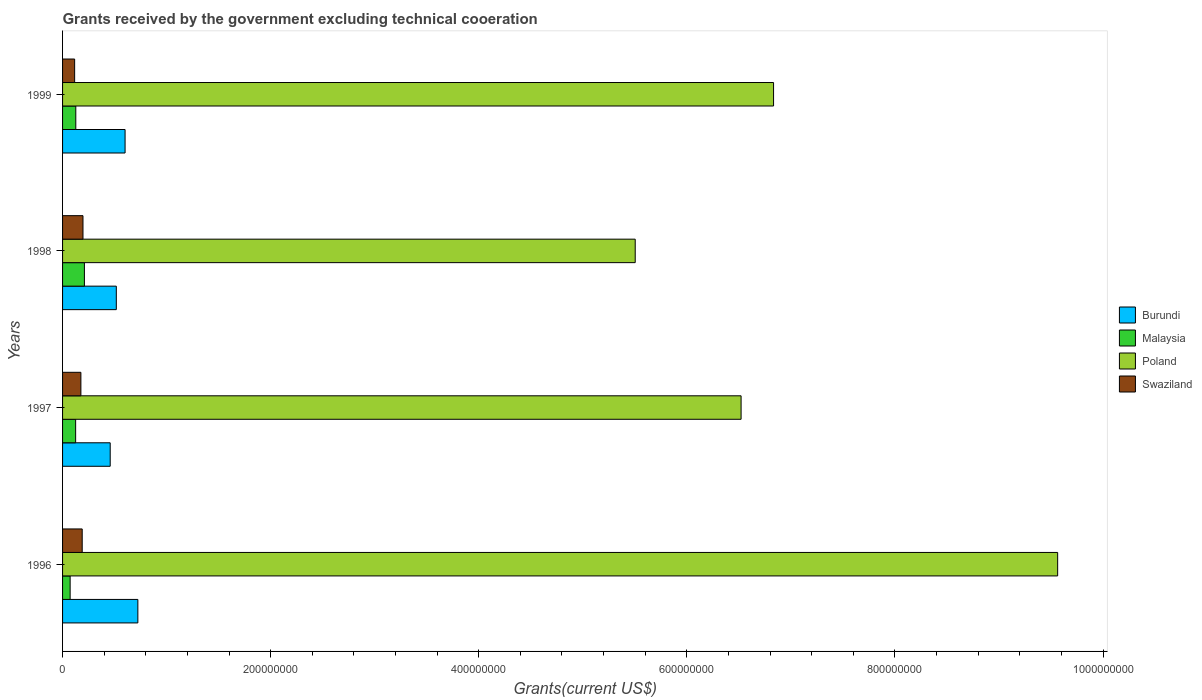How many different coloured bars are there?
Give a very brief answer. 4. Are the number of bars on each tick of the Y-axis equal?
Your answer should be very brief. Yes. How many bars are there on the 4th tick from the top?
Provide a succinct answer. 4. What is the total grants received by the government in Burundi in 1998?
Keep it short and to the point. 5.17e+07. Across all years, what is the maximum total grants received by the government in Malaysia?
Offer a very short reply. 2.10e+07. Across all years, what is the minimum total grants received by the government in Burundi?
Make the answer very short. 4.58e+07. In which year was the total grants received by the government in Malaysia maximum?
Offer a very short reply. 1998. What is the total total grants received by the government in Burundi in the graph?
Make the answer very short. 2.30e+08. What is the difference between the total grants received by the government in Poland in 1997 and that in 1999?
Give a very brief answer. -3.12e+07. What is the difference between the total grants received by the government in Poland in 1997 and the total grants received by the government in Burundi in 1999?
Your answer should be very brief. 5.92e+08. What is the average total grants received by the government in Malaysia per year?
Ensure brevity in your answer.  1.34e+07. In the year 1996, what is the difference between the total grants received by the government in Malaysia and total grants received by the government in Swaziland?
Make the answer very short. -1.16e+07. In how many years, is the total grants received by the government in Swaziland greater than 480000000 US$?
Ensure brevity in your answer.  0. What is the ratio of the total grants received by the government in Burundi in 1997 to that in 1998?
Offer a terse response. 0.89. Is the total grants received by the government in Malaysia in 1996 less than that in 1997?
Keep it short and to the point. Yes. Is the difference between the total grants received by the government in Malaysia in 1998 and 1999 greater than the difference between the total grants received by the government in Swaziland in 1998 and 1999?
Offer a very short reply. Yes. What is the difference between the highest and the second highest total grants received by the government in Burundi?
Offer a terse response. 1.23e+07. What is the difference between the highest and the lowest total grants received by the government in Swaziland?
Your answer should be very brief. 8.02e+06. Is the sum of the total grants received by the government in Burundi in 1997 and 1998 greater than the maximum total grants received by the government in Poland across all years?
Offer a terse response. No. What does the 4th bar from the bottom in 1998 represents?
Keep it short and to the point. Swaziland. Is it the case that in every year, the sum of the total grants received by the government in Burundi and total grants received by the government in Malaysia is greater than the total grants received by the government in Swaziland?
Offer a terse response. Yes. How many bars are there?
Offer a very short reply. 16. How many years are there in the graph?
Offer a very short reply. 4. How many legend labels are there?
Make the answer very short. 4. How are the legend labels stacked?
Offer a very short reply. Vertical. What is the title of the graph?
Give a very brief answer. Grants received by the government excluding technical cooeration. What is the label or title of the X-axis?
Your answer should be compact. Grants(current US$). What is the Grants(current US$) of Burundi in 1996?
Provide a short and direct response. 7.24e+07. What is the Grants(current US$) of Malaysia in 1996?
Provide a short and direct response. 7.28e+06. What is the Grants(current US$) of Poland in 1996?
Give a very brief answer. 9.56e+08. What is the Grants(current US$) of Swaziland in 1996?
Provide a short and direct response. 1.89e+07. What is the Grants(current US$) of Burundi in 1997?
Provide a succinct answer. 4.58e+07. What is the Grants(current US$) in Malaysia in 1997?
Your response must be concise. 1.26e+07. What is the Grants(current US$) of Poland in 1997?
Offer a very short reply. 6.52e+08. What is the Grants(current US$) of Swaziland in 1997?
Make the answer very short. 1.76e+07. What is the Grants(current US$) of Burundi in 1998?
Offer a terse response. 5.17e+07. What is the Grants(current US$) of Malaysia in 1998?
Give a very brief answer. 2.10e+07. What is the Grants(current US$) of Poland in 1998?
Provide a short and direct response. 5.50e+08. What is the Grants(current US$) of Swaziland in 1998?
Offer a terse response. 1.96e+07. What is the Grants(current US$) in Burundi in 1999?
Keep it short and to the point. 6.01e+07. What is the Grants(current US$) in Malaysia in 1999?
Ensure brevity in your answer.  1.27e+07. What is the Grants(current US$) of Poland in 1999?
Make the answer very short. 6.83e+08. What is the Grants(current US$) in Swaziland in 1999?
Your answer should be very brief. 1.16e+07. Across all years, what is the maximum Grants(current US$) in Burundi?
Make the answer very short. 7.24e+07. Across all years, what is the maximum Grants(current US$) in Malaysia?
Give a very brief answer. 2.10e+07. Across all years, what is the maximum Grants(current US$) of Poland?
Ensure brevity in your answer.  9.56e+08. Across all years, what is the maximum Grants(current US$) in Swaziland?
Your answer should be very brief. 1.96e+07. Across all years, what is the minimum Grants(current US$) of Burundi?
Your response must be concise. 4.58e+07. Across all years, what is the minimum Grants(current US$) of Malaysia?
Your answer should be very brief. 7.28e+06. Across all years, what is the minimum Grants(current US$) in Poland?
Your answer should be very brief. 5.50e+08. Across all years, what is the minimum Grants(current US$) of Swaziland?
Provide a succinct answer. 1.16e+07. What is the total Grants(current US$) in Burundi in the graph?
Your response must be concise. 2.30e+08. What is the total Grants(current US$) in Malaysia in the graph?
Give a very brief answer. 5.36e+07. What is the total Grants(current US$) of Poland in the graph?
Your answer should be compact. 2.84e+09. What is the total Grants(current US$) of Swaziland in the graph?
Offer a very short reply. 6.77e+07. What is the difference between the Grants(current US$) in Burundi in 1996 and that in 1997?
Keep it short and to the point. 2.66e+07. What is the difference between the Grants(current US$) of Malaysia in 1996 and that in 1997?
Give a very brief answer. -5.29e+06. What is the difference between the Grants(current US$) of Poland in 1996 and that in 1997?
Your response must be concise. 3.04e+08. What is the difference between the Grants(current US$) of Swaziland in 1996 and that in 1997?
Ensure brevity in your answer.  1.27e+06. What is the difference between the Grants(current US$) in Burundi in 1996 and that in 1998?
Make the answer very short. 2.07e+07. What is the difference between the Grants(current US$) in Malaysia in 1996 and that in 1998?
Your answer should be very brief. -1.37e+07. What is the difference between the Grants(current US$) in Poland in 1996 and that in 1998?
Make the answer very short. 4.06e+08. What is the difference between the Grants(current US$) in Swaziland in 1996 and that in 1998?
Provide a succinct answer. -7.40e+05. What is the difference between the Grants(current US$) of Burundi in 1996 and that in 1999?
Your answer should be very brief. 1.23e+07. What is the difference between the Grants(current US$) of Malaysia in 1996 and that in 1999?
Keep it short and to the point. -5.43e+06. What is the difference between the Grants(current US$) in Poland in 1996 and that in 1999?
Ensure brevity in your answer.  2.73e+08. What is the difference between the Grants(current US$) of Swaziland in 1996 and that in 1999?
Your answer should be compact. 7.28e+06. What is the difference between the Grants(current US$) of Burundi in 1997 and that in 1998?
Make the answer very short. -5.87e+06. What is the difference between the Grants(current US$) in Malaysia in 1997 and that in 1998?
Offer a terse response. -8.42e+06. What is the difference between the Grants(current US$) of Poland in 1997 and that in 1998?
Provide a short and direct response. 1.02e+08. What is the difference between the Grants(current US$) in Swaziland in 1997 and that in 1998?
Ensure brevity in your answer.  -2.01e+06. What is the difference between the Grants(current US$) of Burundi in 1997 and that in 1999?
Ensure brevity in your answer.  -1.43e+07. What is the difference between the Grants(current US$) in Poland in 1997 and that in 1999?
Offer a very short reply. -3.12e+07. What is the difference between the Grants(current US$) of Swaziland in 1997 and that in 1999?
Make the answer very short. 6.01e+06. What is the difference between the Grants(current US$) of Burundi in 1998 and that in 1999?
Make the answer very short. -8.42e+06. What is the difference between the Grants(current US$) in Malaysia in 1998 and that in 1999?
Offer a terse response. 8.28e+06. What is the difference between the Grants(current US$) in Poland in 1998 and that in 1999?
Offer a very short reply. -1.33e+08. What is the difference between the Grants(current US$) of Swaziland in 1998 and that in 1999?
Make the answer very short. 8.02e+06. What is the difference between the Grants(current US$) in Burundi in 1996 and the Grants(current US$) in Malaysia in 1997?
Provide a short and direct response. 5.98e+07. What is the difference between the Grants(current US$) in Burundi in 1996 and the Grants(current US$) in Poland in 1997?
Make the answer very short. -5.80e+08. What is the difference between the Grants(current US$) in Burundi in 1996 and the Grants(current US$) in Swaziland in 1997?
Provide a short and direct response. 5.48e+07. What is the difference between the Grants(current US$) of Malaysia in 1996 and the Grants(current US$) of Poland in 1997?
Provide a short and direct response. -6.45e+08. What is the difference between the Grants(current US$) of Malaysia in 1996 and the Grants(current US$) of Swaziland in 1997?
Your response must be concise. -1.03e+07. What is the difference between the Grants(current US$) in Poland in 1996 and the Grants(current US$) in Swaziland in 1997?
Provide a short and direct response. 9.39e+08. What is the difference between the Grants(current US$) in Burundi in 1996 and the Grants(current US$) in Malaysia in 1998?
Keep it short and to the point. 5.14e+07. What is the difference between the Grants(current US$) in Burundi in 1996 and the Grants(current US$) in Poland in 1998?
Provide a succinct answer. -4.78e+08. What is the difference between the Grants(current US$) of Burundi in 1996 and the Grants(current US$) of Swaziland in 1998?
Provide a succinct answer. 5.27e+07. What is the difference between the Grants(current US$) of Malaysia in 1996 and the Grants(current US$) of Poland in 1998?
Make the answer very short. -5.43e+08. What is the difference between the Grants(current US$) in Malaysia in 1996 and the Grants(current US$) in Swaziland in 1998?
Your answer should be compact. -1.23e+07. What is the difference between the Grants(current US$) in Poland in 1996 and the Grants(current US$) in Swaziland in 1998?
Your answer should be very brief. 9.37e+08. What is the difference between the Grants(current US$) in Burundi in 1996 and the Grants(current US$) in Malaysia in 1999?
Your response must be concise. 5.96e+07. What is the difference between the Grants(current US$) in Burundi in 1996 and the Grants(current US$) in Poland in 1999?
Your answer should be compact. -6.11e+08. What is the difference between the Grants(current US$) in Burundi in 1996 and the Grants(current US$) in Swaziland in 1999?
Offer a terse response. 6.08e+07. What is the difference between the Grants(current US$) of Malaysia in 1996 and the Grants(current US$) of Poland in 1999?
Give a very brief answer. -6.76e+08. What is the difference between the Grants(current US$) of Malaysia in 1996 and the Grants(current US$) of Swaziland in 1999?
Your answer should be compact. -4.32e+06. What is the difference between the Grants(current US$) of Poland in 1996 and the Grants(current US$) of Swaziland in 1999?
Offer a very short reply. 9.45e+08. What is the difference between the Grants(current US$) of Burundi in 1997 and the Grants(current US$) of Malaysia in 1998?
Keep it short and to the point. 2.48e+07. What is the difference between the Grants(current US$) in Burundi in 1997 and the Grants(current US$) in Poland in 1998?
Ensure brevity in your answer.  -5.05e+08. What is the difference between the Grants(current US$) in Burundi in 1997 and the Grants(current US$) in Swaziland in 1998?
Ensure brevity in your answer.  2.62e+07. What is the difference between the Grants(current US$) in Malaysia in 1997 and the Grants(current US$) in Poland in 1998?
Provide a short and direct response. -5.38e+08. What is the difference between the Grants(current US$) of Malaysia in 1997 and the Grants(current US$) of Swaziland in 1998?
Offer a terse response. -7.05e+06. What is the difference between the Grants(current US$) in Poland in 1997 and the Grants(current US$) in Swaziland in 1998?
Ensure brevity in your answer.  6.33e+08. What is the difference between the Grants(current US$) in Burundi in 1997 and the Grants(current US$) in Malaysia in 1999?
Provide a short and direct response. 3.31e+07. What is the difference between the Grants(current US$) of Burundi in 1997 and the Grants(current US$) of Poland in 1999?
Offer a very short reply. -6.38e+08. What is the difference between the Grants(current US$) in Burundi in 1997 and the Grants(current US$) in Swaziland in 1999?
Keep it short and to the point. 3.42e+07. What is the difference between the Grants(current US$) of Malaysia in 1997 and the Grants(current US$) of Poland in 1999?
Your response must be concise. -6.71e+08. What is the difference between the Grants(current US$) in Malaysia in 1997 and the Grants(current US$) in Swaziland in 1999?
Your response must be concise. 9.70e+05. What is the difference between the Grants(current US$) of Poland in 1997 and the Grants(current US$) of Swaziland in 1999?
Give a very brief answer. 6.41e+08. What is the difference between the Grants(current US$) of Burundi in 1998 and the Grants(current US$) of Malaysia in 1999?
Provide a succinct answer. 3.90e+07. What is the difference between the Grants(current US$) of Burundi in 1998 and the Grants(current US$) of Poland in 1999?
Provide a succinct answer. -6.32e+08. What is the difference between the Grants(current US$) of Burundi in 1998 and the Grants(current US$) of Swaziland in 1999?
Make the answer very short. 4.01e+07. What is the difference between the Grants(current US$) of Malaysia in 1998 and the Grants(current US$) of Poland in 1999?
Provide a short and direct response. -6.62e+08. What is the difference between the Grants(current US$) of Malaysia in 1998 and the Grants(current US$) of Swaziland in 1999?
Make the answer very short. 9.39e+06. What is the difference between the Grants(current US$) in Poland in 1998 and the Grants(current US$) in Swaziland in 1999?
Provide a succinct answer. 5.39e+08. What is the average Grants(current US$) in Burundi per year?
Your response must be concise. 5.75e+07. What is the average Grants(current US$) in Malaysia per year?
Your answer should be very brief. 1.34e+07. What is the average Grants(current US$) of Poland per year?
Provide a succinct answer. 7.11e+08. What is the average Grants(current US$) of Swaziland per year?
Keep it short and to the point. 1.69e+07. In the year 1996, what is the difference between the Grants(current US$) in Burundi and Grants(current US$) in Malaysia?
Your response must be concise. 6.51e+07. In the year 1996, what is the difference between the Grants(current US$) in Burundi and Grants(current US$) in Poland?
Give a very brief answer. -8.84e+08. In the year 1996, what is the difference between the Grants(current US$) in Burundi and Grants(current US$) in Swaziland?
Give a very brief answer. 5.35e+07. In the year 1996, what is the difference between the Grants(current US$) in Malaysia and Grants(current US$) in Poland?
Keep it short and to the point. -9.49e+08. In the year 1996, what is the difference between the Grants(current US$) in Malaysia and Grants(current US$) in Swaziland?
Offer a very short reply. -1.16e+07. In the year 1996, what is the difference between the Grants(current US$) of Poland and Grants(current US$) of Swaziland?
Offer a very short reply. 9.38e+08. In the year 1997, what is the difference between the Grants(current US$) of Burundi and Grants(current US$) of Malaysia?
Offer a very short reply. 3.32e+07. In the year 1997, what is the difference between the Grants(current US$) of Burundi and Grants(current US$) of Poland?
Give a very brief answer. -6.06e+08. In the year 1997, what is the difference between the Grants(current US$) in Burundi and Grants(current US$) in Swaziland?
Your answer should be very brief. 2.82e+07. In the year 1997, what is the difference between the Grants(current US$) in Malaysia and Grants(current US$) in Poland?
Give a very brief answer. -6.40e+08. In the year 1997, what is the difference between the Grants(current US$) of Malaysia and Grants(current US$) of Swaziland?
Provide a succinct answer. -5.04e+06. In the year 1997, what is the difference between the Grants(current US$) in Poland and Grants(current US$) in Swaziland?
Ensure brevity in your answer.  6.35e+08. In the year 1998, what is the difference between the Grants(current US$) of Burundi and Grants(current US$) of Malaysia?
Keep it short and to the point. 3.07e+07. In the year 1998, what is the difference between the Grants(current US$) of Burundi and Grants(current US$) of Poland?
Give a very brief answer. -4.99e+08. In the year 1998, what is the difference between the Grants(current US$) in Burundi and Grants(current US$) in Swaziland?
Your answer should be very brief. 3.20e+07. In the year 1998, what is the difference between the Grants(current US$) of Malaysia and Grants(current US$) of Poland?
Offer a terse response. -5.29e+08. In the year 1998, what is the difference between the Grants(current US$) in Malaysia and Grants(current US$) in Swaziland?
Offer a very short reply. 1.37e+06. In the year 1998, what is the difference between the Grants(current US$) of Poland and Grants(current US$) of Swaziland?
Provide a succinct answer. 5.31e+08. In the year 1999, what is the difference between the Grants(current US$) in Burundi and Grants(current US$) in Malaysia?
Your answer should be very brief. 4.74e+07. In the year 1999, what is the difference between the Grants(current US$) in Burundi and Grants(current US$) in Poland?
Keep it short and to the point. -6.23e+08. In the year 1999, what is the difference between the Grants(current US$) of Burundi and Grants(current US$) of Swaziland?
Offer a very short reply. 4.85e+07. In the year 1999, what is the difference between the Grants(current US$) of Malaysia and Grants(current US$) of Poland?
Offer a very short reply. -6.71e+08. In the year 1999, what is the difference between the Grants(current US$) in Malaysia and Grants(current US$) in Swaziland?
Offer a very short reply. 1.11e+06. In the year 1999, what is the difference between the Grants(current US$) of Poland and Grants(current US$) of Swaziland?
Your response must be concise. 6.72e+08. What is the ratio of the Grants(current US$) in Burundi in 1996 to that in 1997?
Your answer should be very brief. 1.58. What is the ratio of the Grants(current US$) of Malaysia in 1996 to that in 1997?
Offer a terse response. 0.58. What is the ratio of the Grants(current US$) of Poland in 1996 to that in 1997?
Keep it short and to the point. 1.47. What is the ratio of the Grants(current US$) of Swaziland in 1996 to that in 1997?
Offer a very short reply. 1.07. What is the ratio of the Grants(current US$) in Burundi in 1996 to that in 1998?
Your answer should be compact. 1.4. What is the ratio of the Grants(current US$) in Malaysia in 1996 to that in 1998?
Make the answer very short. 0.35. What is the ratio of the Grants(current US$) in Poland in 1996 to that in 1998?
Your response must be concise. 1.74. What is the ratio of the Grants(current US$) of Swaziland in 1996 to that in 1998?
Your answer should be very brief. 0.96. What is the ratio of the Grants(current US$) in Burundi in 1996 to that in 1999?
Offer a terse response. 1.2. What is the ratio of the Grants(current US$) of Malaysia in 1996 to that in 1999?
Keep it short and to the point. 0.57. What is the ratio of the Grants(current US$) in Poland in 1996 to that in 1999?
Ensure brevity in your answer.  1.4. What is the ratio of the Grants(current US$) of Swaziland in 1996 to that in 1999?
Provide a short and direct response. 1.63. What is the ratio of the Grants(current US$) in Burundi in 1997 to that in 1998?
Give a very brief answer. 0.89. What is the ratio of the Grants(current US$) of Malaysia in 1997 to that in 1998?
Ensure brevity in your answer.  0.6. What is the ratio of the Grants(current US$) of Poland in 1997 to that in 1998?
Your response must be concise. 1.18. What is the ratio of the Grants(current US$) in Swaziland in 1997 to that in 1998?
Your answer should be compact. 0.9. What is the ratio of the Grants(current US$) of Burundi in 1997 to that in 1999?
Your response must be concise. 0.76. What is the ratio of the Grants(current US$) in Malaysia in 1997 to that in 1999?
Keep it short and to the point. 0.99. What is the ratio of the Grants(current US$) in Poland in 1997 to that in 1999?
Your answer should be very brief. 0.95. What is the ratio of the Grants(current US$) in Swaziland in 1997 to that in 1999?
Offer a terse response. 1.52. What is the ratio of the Grants(current US$) in Burundi in 1998 to that in 1999?
Offer a very short reply. 0.86. What is the ratio of the Grants(current US$) of Malaysia in 1998 to that in 1999?
Give a very brief answer. 1.65. What is the ratio of the Grants(current US$) of Poland in 1998 to that in 1999?
Your answer should be compact. 0.81. What is the ratio of the Grants(current US$) in Swaziland in 1998 to that in 1999?
Ensure brevity in your answer.  1.69. What is the difference between the highest and the second highest Grants(current US$) of Burundi?
Make the answer very short. 1.23e+07. What is the difference between the highest and the second highest Grants(current US$) of Malaysia?
Ensure brevity in your answer.  8.28e+06. What is the difference between the highest and the second highest Grants(current US$) of Poland?
Provide a short and direct response. 2.73e+08. What is the difference between the highest and the second highest Grants(current US$) of Swaziland?
Offer a very short reply. 7.40e+05. What is the difference between the highest and the lowest Grants(current US$) of Burundi?
Your response must be concise. 2.66e+07. What is the difference between the highest and the lowest Grants(current US$) in Malaysia?
Give a very brief answer. 1.37e+07. What is the difference between the highest and the lowest Grants(current US$) of Poland?
Give a very brief answer. 4.06e+08. What is the difference between the highest and the lowest Grants(current US$) of Swaziland?
Your response must be concise. 8.02e+06. 